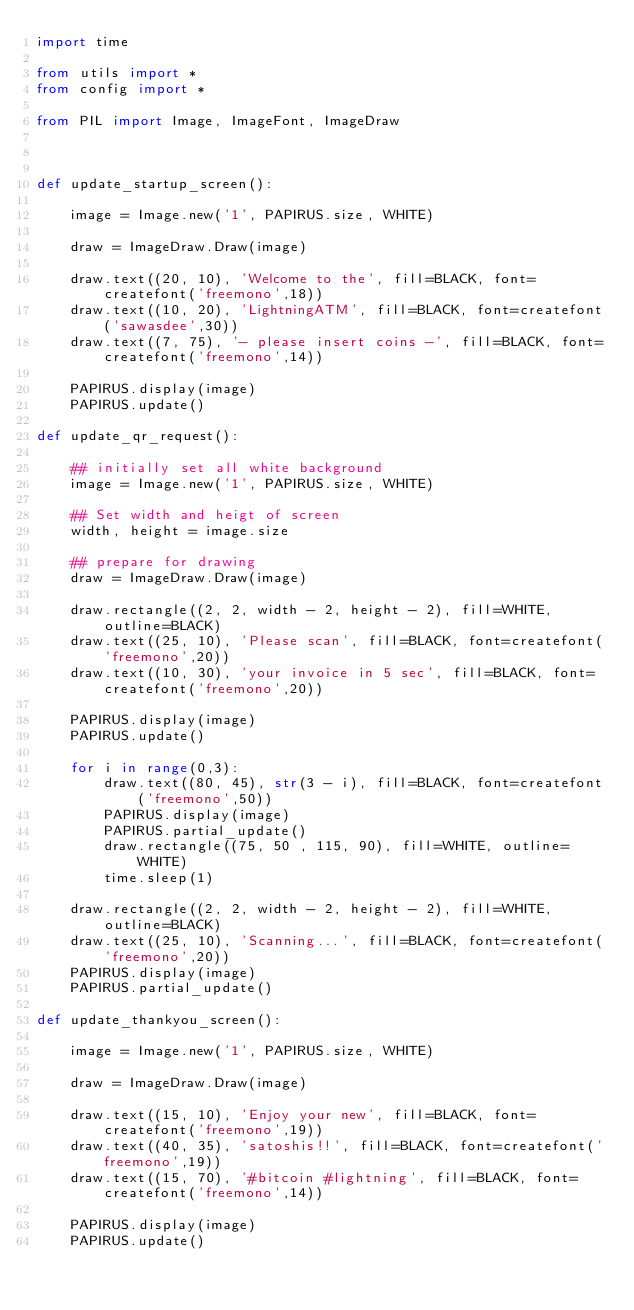Convert code to text. <code><loc_0><loc_0><loc_500><loc_500><_Python_>import time

from utils import *
from config import *

from PIL import Image, ImageFont, ImageDraw



def update_startup_screen():

    image = Image.new('1', PAPIRUS.size, WHITE)

    draw = ImageDraw.Draw(image)

    draw.text((20, 10), 'Welcome to the', fill=BLACK, font=createfont('freemono',18))
    draw.text((10, 20), 'LightningATM', fill=BLACK, font=createfont('sawasdee',30))
    draw.text((7, 75), '- please insert coins -', fill=BLACK, font=createfont('freemono',14))

    PAPIRUS.display(image)
    PAPIRUS.update()

def update_qr_request():

    ## initially set all white background
    image = Image.new('1', PAPIRUS.size, WHITE)

    ## Set width and heigt of screen
    width, height = image.size

    ## prepare for drawing
    draw = ImageDraw.Draw(image)

    draw.rectangle((2, 2, width - 2, height - 2), fill=WHITE, outline=BLACK)
    draw.text((25, 10), 'Please scan', fill=BLACK, font=createfont('freemono',20))
    draw.text((10, 30), 'your invoice in 5 sec', fill=BLACK, font=createfont('freemono',20))

    PAPIRUS.display(image)
    PAPIRUS.update()

    for i in range(0,3):
        draw.text((80, 45), str(3 - i), fill=BLACK, font=createfont('freemono',50))
        PAPIRUS.display(image)
        PAPIRUS.partial_update()
        draw.rectangle((75, 50 , 115, 90), fill=WHITE, outline=WHITE)
        time.sleep(1)

    draw.rectangle((2, 2, width - 2, height - 2), fill=WHITE, outline=BLACK)
    draw.text((25, 10), 'Scanning...', fill=BLACK, font=createfont('freemono',20))
    PAPIRUS.display(image)
    PAPIRUS.partial_update()

def update_thankyou_screen():

    image = Image.new('1', PAPIRUS.size, WHITE)

    draw = ImageDraw.Draw(image)

    draw.text((15, 10), 'Enjoy your new', fill=BLACK, font=createfont('freemono',19))
    draw.text((40, 35), 'satoshis!!', fill=BLACK, font=createfont('freemono',19))
    draw.text((15, 70), '#bitcoin #lightning', fill=BLACK, font=createfont('freemono',14))

    PAPIRUS.display(image)
    PAPIRUS.update()
</code> 